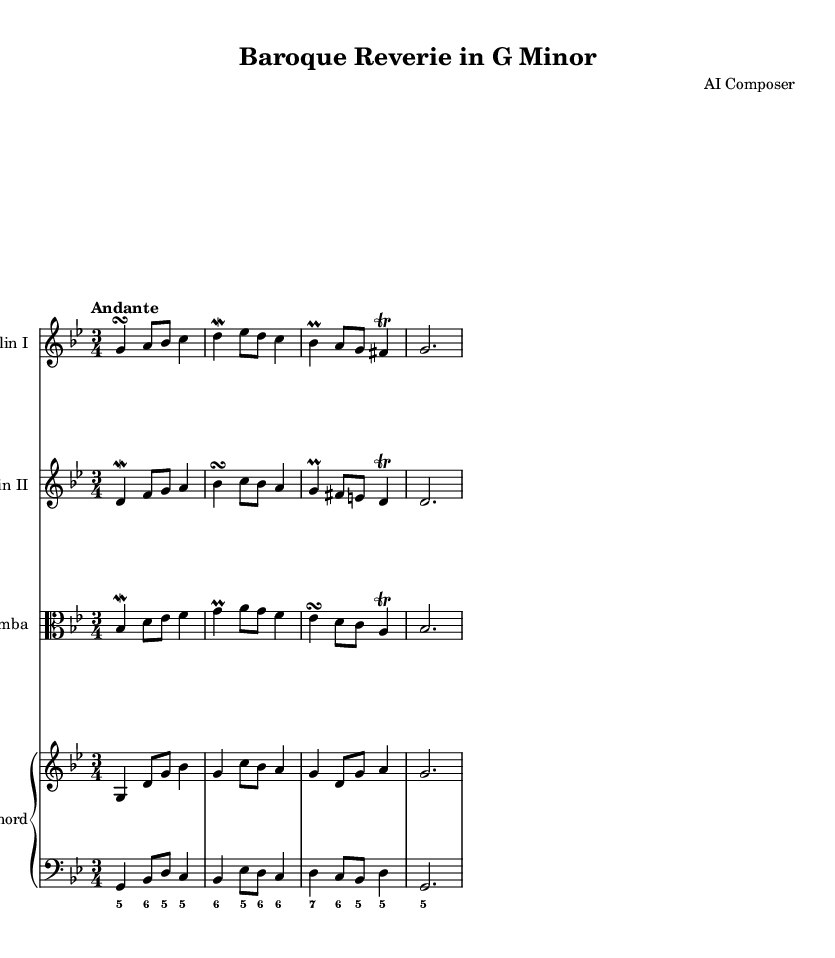What is the key signature of this music? The key signature is G minor, which has two flats (B flat and E flat). This can be identified by looking at the beginning of the staff where the key signature is indicated.
Answer: G minor What is the time signature of this score? The time signature is 3/4, which can be observed at the start of each staff where it shows three beats per measure with a quarter note receiving one beat.
Answer: 3/4 What is the tempo marking for this piece? The tempo marking is "Andante," which is indicated in the header above the music and suggests a moderately slow pace.
Answer: Andante Which instruments are featured in this chamber music? The instruments included are Violin I, Violin II, Viola da gamba, and Harpsichord (with two staves for right and left hands). This can be determined from the labels at the beginning of each staff showing the respective instruments.
Answer: Violin I, Violin II, Viola da gamba, Harpsichord How many voices are present in the counterpoint of this piece? There are four distinct voices represented by the parts for each instrument: two violins, one viola da gamba, and one harpsichord playing both treble and bass. The interplay of these parts illustrates the intricate counterpoint typical of Baroque music.
Answer: Four What type of ornamentation is used in the violin part? The violin part includes turns, mordents, trills, and prall. These notations are clearly visible as they are written next to specific notes in the violin lines, indicating the specific embellishments typical in Baroque compositions.
Answer: Turns, mordents, trills, prall How does the harpsichord function in this music? The harpsichord serves both a harmonic and rhythmic role, providing accompaniment to the melodic lines of the violins and viola da gamba. Its figured bass notation indicates chordal support, enhancing the overall texture of the piece.
Answer: Harmonic and rhythmic support 